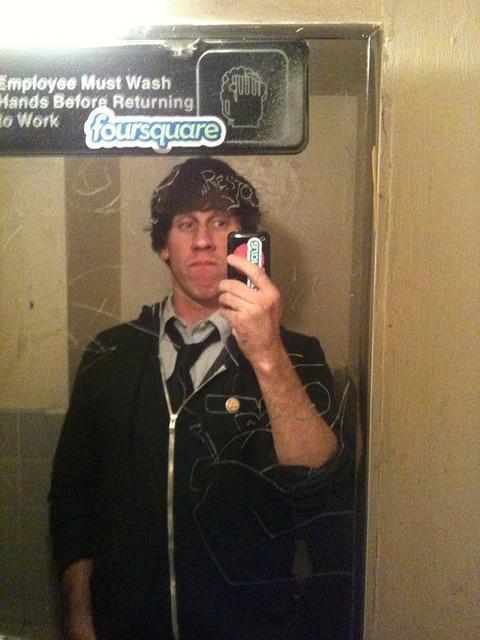Who took the photo of this man?
Choose the correct response and explain in the format: 'Answer: answer
Rationale: rationale.'
Options: This man, professional photographer, another woman, blackmailer. Answer: this man.
Rationale: The man took the picture of himself. Who is taking this man's picture?
Make your selection from the four choices given to correctly answer the question.
Options: Teen friend, no one, studio photographer, he is. He is. 